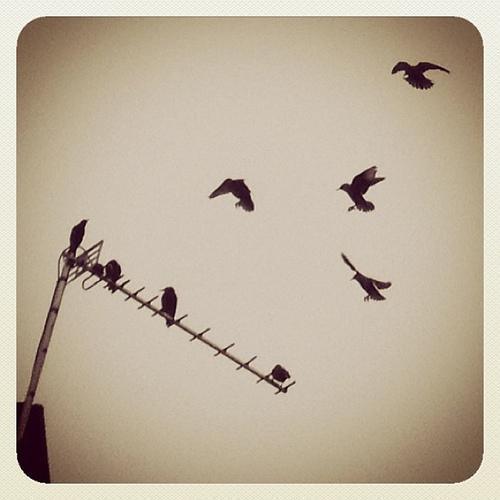How many birds are flying?
Give a very brief answer. 4. 